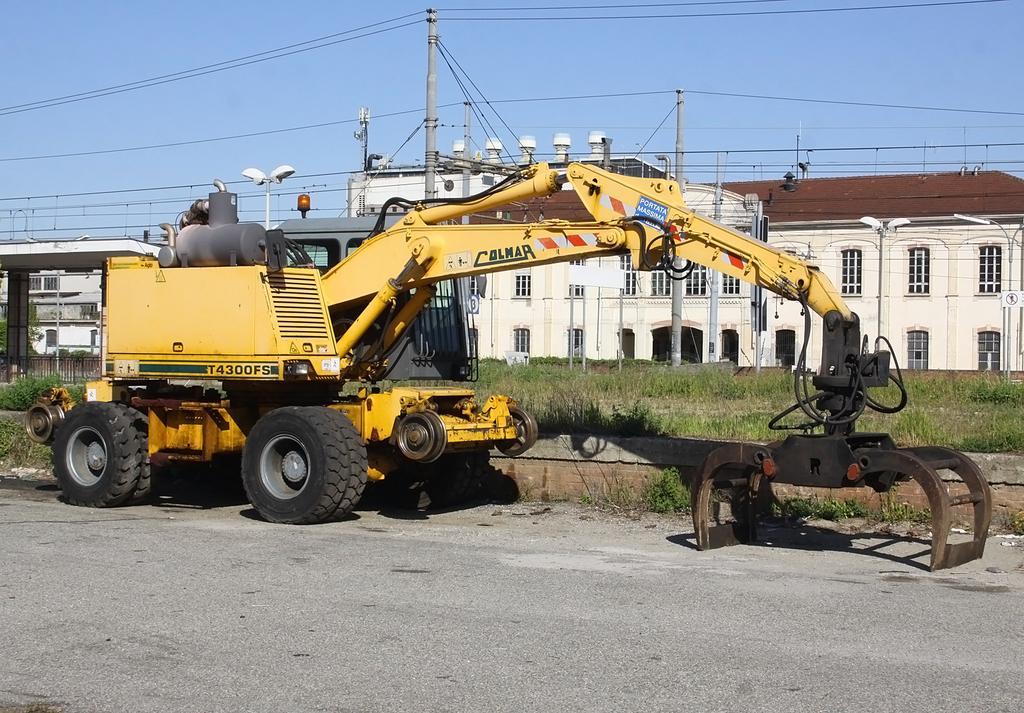Can you describe this image briefly? In this image there is the sky truncated towards the top of the image, there are buildings, there is a building truncated towards the right of the image, there is a building truncated towards the left of the image, there are windows, there is grass truncated towards the right of the image, there are plants, there are poles, there are wires truncated, there are street lights, there is the road truncated towards the bottom of the image, there is a vehicle on the road. 